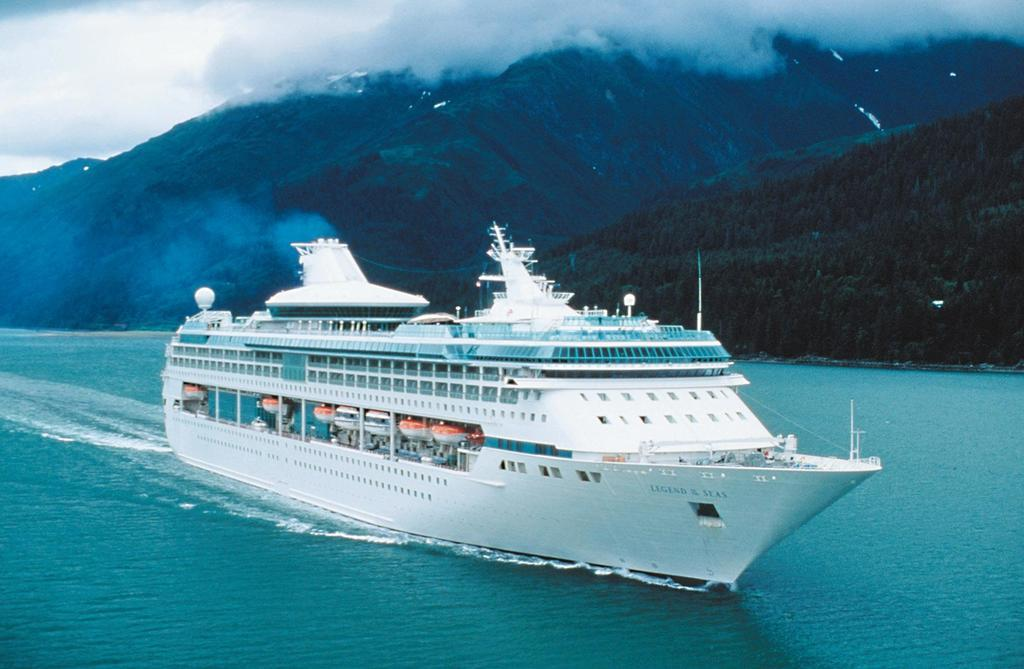What is the main subject of the image? There is a ship in the image. Where is the ship located? The ship is in water. What can be seen in the background of the image? There are mountains and the sky visible in the background of the image. What type of pie is being served on the ship in the image? There is no pie present in the image; it features a ship in water with mountains and the sky visible in the background. 